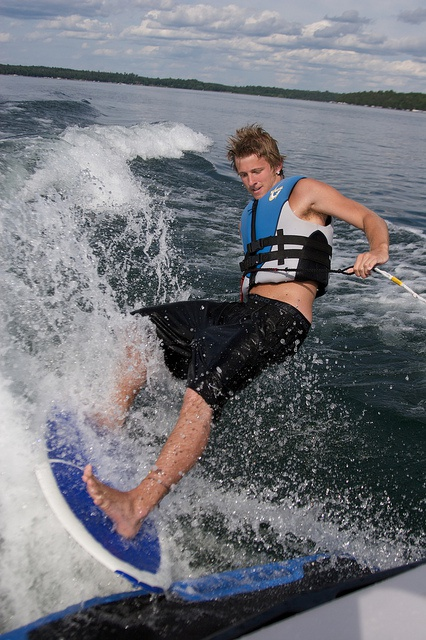Describe the objects in this image and their specific colors. I can see people in gray, black, salmon, and darkgray tones and surfboard in gray, darkgray, navy, and lightgray tones in this image. 